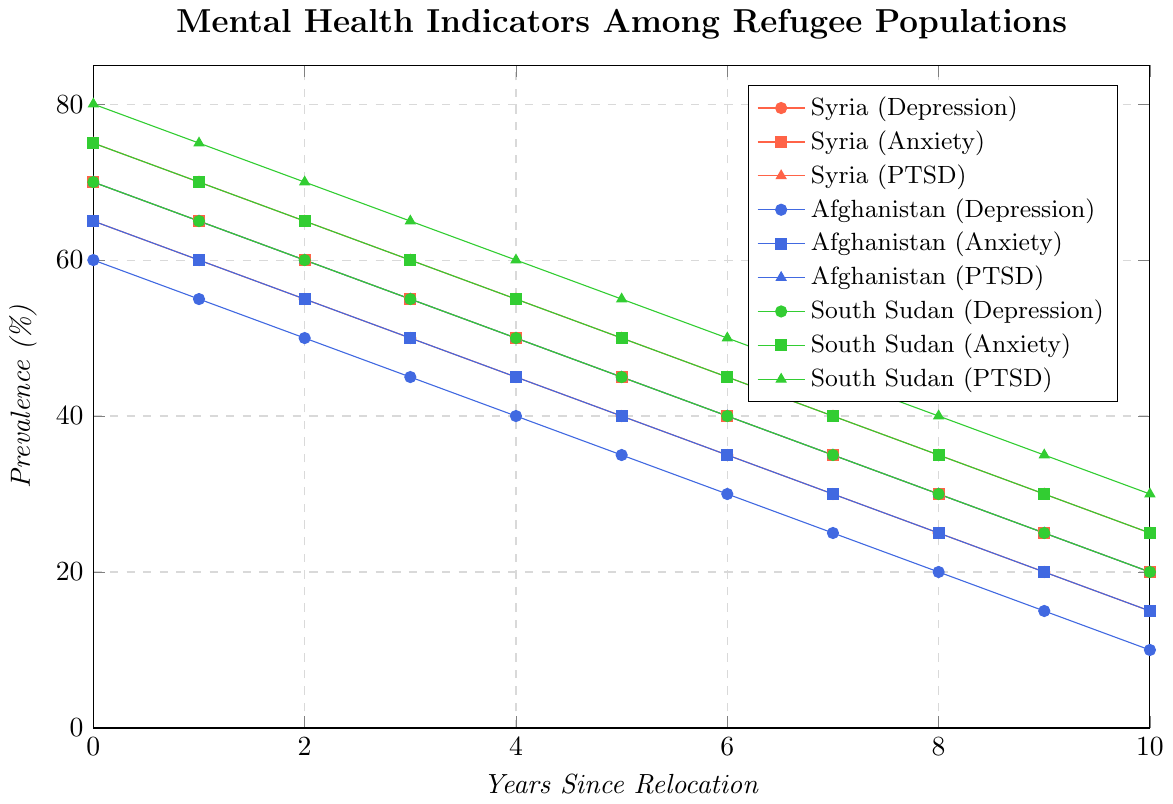Which country shows the highest initial prevalence of PTSD in year 0? Identify the PTSD line for each country at year 0: Syria (75%), Afghanistan (70%), South Sudan (80%). South Sudan has the highest initial prevalence.
Answer: South Sudan How does the prevalence of depression in Syria at year 3 compare to that in South Sudan at year 3? Refer to the depression line for both countries at year 3: Syria (50%), South Sudan (55%). South Sudan has a higher prevalence of depression at year 3.
Answer: South Sudan What is the average prevalence of anxiety in Afghanistan over the 10-year period? Sum the prevalence percentages of anxiety in Afghanistan for each year and divide by 11: (65 + 60 + 55 + 50 + 45 + 40 + 35 + 30 + 25 + 20 + 15) / 11 = 440 / 11 = 40%.
Answer: 40% Which mental health indicator shows the most rapid decrease over time in South Sudan? Look at the slopes of the South Sudan lines: PTSD (80% to 30%), Anxiety (75% to 25%), Depression (70% to 20%). PTSD decreases the most rapidly.
Answer: PTSD By how many percentage points does anxiety in Syria decrease from year 2 to year 6? Subtract the value of anxiety in Syria at year 6 from the value at year 2: 60% - 40% = 20 percentage points.
Answer: 20 Is there ever a year when the prevalence of PTSD in Afghanistan is lower than the prevalence of depression in South Sudan? Compare PTSD in Afghanistan and depression in South Sudan for each year; for example, year 0: 70% (Afg PTSD) vs. 70% (SS Dep); year 1: 65% (Afg PTSD) vs. 65% (SS Dep), etc. PTSD in Afghanistan is always higher.
Answer: No What is the difference in the prevalence of depression between Syria and Afghanistan in year 5? Subtract the prevalence percentages for the two countries at year 5: Syria (40%) - Afghanistan (35%) = 5 percentage points.
Answer: 5 Which country has the smallest decrease in PTSD prevalence from year 0 to year 10? Calculate the decrease for each country: Syria (75% - 25% = 50%), Afghanistan (70% - 20% = 50%), South Sudan (80% - 30% = 50%). All three countries have the same decrease.
Answer: All have the same decrease What is the prevalence trend of anxiety in South Sudan from year 0 to year 10? Observe the anxiety line for South Sudan over the years: it consistently decreases from 75% to 25%.
Answer: Decreasing trend 